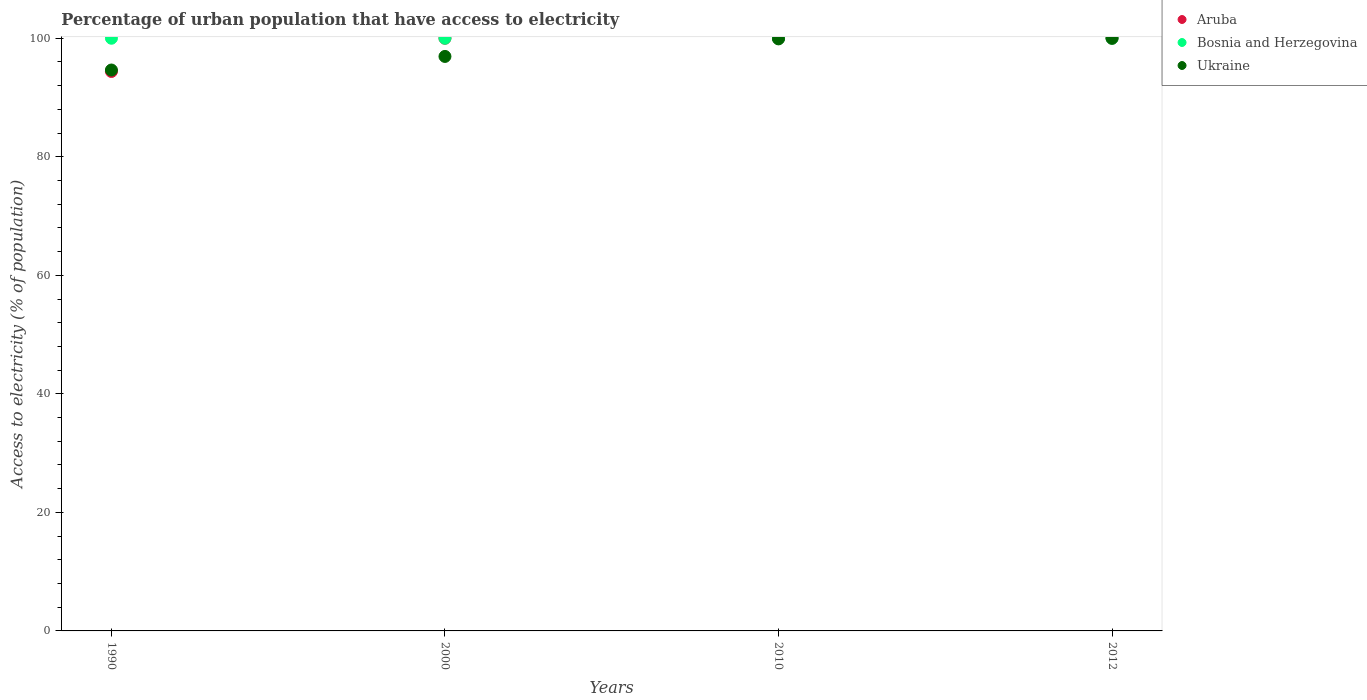What is the percentage of urban population that have access to electricity in Bosnia and Herzegovina in 2010?
Offer a very short reply. 100. Across all years, what is the maximum percentage of urban population that have access to electricity in Bosnia and Herzegovina?
Your response must be concise. 100. Across all years, what is the minimum percentage of urban population that have access to electricity in Aruba?
Keep it short and to the point. 94.39. In which year was the percentage of urban population that have access to electricity in Aruba maximum?
Offer a terse response. 2000. What is the total percentage of urban population that have access to electricity in Ukraine in the graph?
Offer a terse response. 391.46. What is the difference between the percentage of urban population that have access to electricity in Ukraine in 2010 and that in 2012?
Provide a short and direct response. -0.11. What is the difference between the percentage of urban population that have access to electricity in Ukraine in 1990 and the percentage of urban population that have access to electricity in Bosnia and Herzegovina in 2010?
Your answer should be very brief. -5.36. What is the average percentage of urban population that have access to electricity in Bosnia and Herzegovina per year?
Provide a short and direct response. 100. In the year 2012, what is the difference between the percentage of urban population that have access to electricity in Ukraine and percentage of urban population that have access to electricity in Aruba?
Your answer should be very brief. 0. In how many years, is the percentage of urban population that have access to electricity in Bosnia and Herzegovina greater than 20 %?
Ensure brevity in your answer.  4. Is the percentage of urban population that have access to electricity in Ukraine in 2010 less than that in 2012?
Offer a terse response. Yes. Is the difference between the percentage of urban population that have access to electricity in Ukraine in 1990 and 2012 greater than the difference between the percentage of urban population that have access to electricity in Aruba in 1990 and 2012?
Provide a succinct answer. Yes. What is the difference between the highest and the lowest percentage of urban population that have access to electricity in Aruba?
Provide a succinct answer. 5.61. Does the percentage of urban population that have access to electricity in Ukraine monotonically increase over the years?
Provide a short and direct response. Yes. Is the percentage of urban population that have access to electricity in Ukraine strictly greater than the percentage of urban population that have access to electricity in Bosnia and Herzegovina over the years?
Your response must be concise. No. What is the difference between two consecutive major ticks on the Y-axis?
Provide a succinct answer. 20. Does the graph contain any zero values?
Ensure brevity in your answer.  No. How are the legend labels stacked?
Give a very brief answer. Vertical. What is the title of the graph?
Ensure brevity in your answer.  Percentage of urban population that have access to electricity. What is the label or title of the X-axis?
Your answer should be very brief. Years. What is the label or title of the Y-axis?
Your answer should be compact. Access to electricity (% of population). What is the Access to electricity (% of population) of Aruba in 1990?
Make the answer very short. 94.39. What is the Access to electricity (% of population) in Ukraine in 1990?
Your answer should be very brief. 94.64. What is the Access to electricity (% of population) in Ukraine in 2000?
Offer a very short reply. 96.93. What is the Access to electricity (% of population) in Bosnia and Herzegovina in 2010?
Your answer should be compact. 100. What is the Access to electricity (% of population) in Ukraine in 2010?
Ensure brevity in your answer.  99.89. Across all years, what is the maximum Access to electricity (% of population) in Aruba?
Provide a succinct answer. 100. Across all years, what is the maximum Access to electricity (% of population) in Bosnia and Herzegovina?
Your response must be concise. 100. Across all years, what is the minimum Access to electricity (% of population) of Aruba?
Make the answer very short. 94.39. Across all years, what is the minimum Access to electricity (% of population) of Ukraine?
Ensure brevity in your answer.  94.64. What is the total Access to electricity (% of population) of Aruba in the graph?
Offer a terse response. 394.39. What is the total Access to electricity (% of population) in Ukraine in the graph?
Your answer should be compact. 391.46. What is the difference between the Access to electricity (% of population) of Aruba in 1990 and that in 2000?
Provide a short and direct response. -5.61. What is the difference between the Access to electricity (% of population) of Bosnia and Herzegovina in 1990 and that in 2000?
Your response must be concise. 0. What is the difference between the Access to electricity (% of population) in Ukraine in 1990 and that in 2000?
Make the answer very short. -2.29. What is the difference between the Access to electricity (% of population) in Aruba in 1990 and that in 2010?
Your answer should be very brief. -5.61. What is the difference between the Access to electricity (% of population) in Ukraine in 1990 and that in 2010?
Offer a very short reply. -5.25. What is the difference between the Access to electricity (% of population) of Aruba in 1990 and that in 2012?
Make the answer very short. -5.61. What is the difference between the Access to electricity (% of population) in Ukraine in 1990 and that in 2012?
Your answer should be compact. -5.36. What is the difference between the Access to electricity (% of population) of Aruba in 2000 and that in 2010?
Your answer should be very brief. 0. What is the difference between the Access to electricity (% of population) in Ukraine in 2000 and that in 2010?
Your answer should be very brief. -2.96. What is the difference between the Access to electricity (% of population) of Aruba in 2000 and that in 2012?
Your answer should be compact. 0. What is the difference between the Access to electricity (% of population) in Ukraine in 2000 and that in 2012?
Offer a very short reply. -3.07. What is the difference between the Access to electricity (% of population) in Aruba in 2010 and that in 2012?
Your answer should be compact. 0. What is the difference between the Access to electricity (% of population) of Ukraine in 2010 and that in 2012?
Keep it short and to the point. -0.11. What is the difference between the Access to electricity (% of population) of Aruba in 1990 and the Access to electricity (% of population) of Bosnia and Herzegovina in 2000?
Ensure brevity in your answer.  -5.61. What is the difference between the Access to electricity (% of population) in Aruba in 1990 and the Access to electricity (% of population) in Ukraine in 2000?
Your response must be concise. -2.54. What is the difference between the Access to electricity (% of population) in Bosnia and Herzegovina in 1990 and the Access to electricity (% of population) in Ukraine in 2000?
Give a very brief answer. 3.07. What is the difference between the Access to electricity (% of population) in Aruba in 1990 and the Access to electricity (% of population) in Bosnia and Herzegovina in 2010?
Your answer should be compact. -5.61. What is the difference between the Access to electricity (% of population) in Aruba in 1990 and the Access to electricity (% of population) in Ukraine in 2010?
Provide a short and direct response. -5.5. What is the difference between the Access to electricity (% of population) in Bosnia and Herzegovina in 1990 and the Access to electricity (% of population) in Ukraine in 2010?
Keep it short and to the point. 0.11. What is the difference between the Access to electricity (% of population) of Aruba in 1990 and the Access to electricity (% of population) of Bosnia and Herzegovina in 2012?
Offer a terse response. -5.61. What is the difference between the Access to electricity (% of population) in Aruba in 1990 and the Access to electricity (% of population) in Ukraine in 2012?
Offer a very short reply. -5.61. What is the difference between the Access to electricity (% of population) in Aruba in 2000 and the Access to electricity (% of population) in Ukraine in 2010?
Your answer should be compact. 0.11. What is the difference between the Access to electricity (% of population) in Bosnia and Herzegovina in 2000 and the Access to electricity (% of population) in Ukraine in 2010?
Your response must be concise. 0.11. What is the difference between the Access to electricity (% of population) of Aruba in 2000 and the Access to electricity (% of population) of Bosnia and Herzegovina in 2012?
Keep it short and to the point. 0. What is the difference between the Access to electricity (% of population) of Aruba in 2010 and the Access to electricity (% of population) of Bosnia and Herzegovina in 2012?
Offer a terse response. 0. What is the difference between the Access to electricity (% of population) of Aruba in 2010 and the Access to electricity (% of population) of Ukraine in 2012?
Make the answer very short. 0. What is the difference between the Access to electricity (% of population) of Bosnia and Herzegovina in 2010 and the Access to electricity (% of population) of Ukraine in 2012?
Your answer should be compact. 0. What is the average Access to electricity (% of population) in Aruba per year?
Keep it short and to the point. 98.6. What is the average Access to electricity (% of population) of Bosnia and Herzegovina per year?
Give a very brief answer. 100. What is the average Access to electricity (% of population) of Ukraine per year?
Offer a terse response. 97.86. In the year 1990, what is the difference between the Access to electricity (% of population) of Aruba and Access to electricity (% of population) of Bosnia and Herzegovina?
Keep it short and to the point. -5.61. In the year 1990, what is the difference between the Access to electricity (% of population) in Aruba and Access to electricity (% of population) in Ukraine?
Your answer should be very brief. -0.25. In the year 1990, what is the difference between the Access to electricity (% of population) in Bosnia and Herzegovina and Access to electricity (% of population) in Ukraine?
Provide a short and direct response. 5.36. In the year 2000, what is the difference between the Access to electricity (% of population) in Aruba and Access to electricity (% of population) in Bosnia and Herzegovina?
Your answer should be very brief. 0. In the year 2000, what is the difference between the Access to electricity (% of population) in Aruba and Access to electricity (% of population) in Ukraine?
Offer a very short reply. 3.07. In the year 2000, what is the difference between the Access to electricity (% of population) of Bosnia and Herzegovina and Access to electricity (% of population) of Ukraine?
Your answer should be compact. 3.07. In the year 2010, what is the difference between the Access to electricity (% of population) of Aruba and Access to electricity (% of population) of Bosnia and Herzegovina?
Your answer should be very brief. 0. In the year 2010, what is the difference between the Access to electricity (% of population) of Aruba and Access to electricity (% of population) of Ukraine?
Keep it short and to the point. 0.11. In the year 2010, what is the difference between the Access to electricity (% of population) of Bosnia and Herzegovina and Access to electricity (% of population) of Ukraine?
Your answer should be compact. 0.11. In the year 2012, what is the difference between the Access to electricity (% of population) in Aruba and Access to electricity (% of population) in Ukraine?
Provide a succinct answer. 0. What is the ratio of the Access to electricity (% of population) in Aruba in 1990 to that in 2000?
Your answer should be very brief. 0.94. What is the ratio of the Access to electricity (% of population) of Ukraine in 1990 to that in 2000?
Your response must be concise. 0.98. What is the ratio of the Access to electricity (% of population) in Aruba in 1990 to that in 2010?
Provide a succinct answer. 0.94. What is the ratio of the Access to electricity (% of population) of Bosnia and Herzegovina in 1990 to that in 2010?
Provide a succinct answer. 1. What is the ratio of the Access to electricity (% of population) of Ukraine in 1990 to that in 2010?
Keep it short and to the point. 0.95. What is the ratio of the Access to electricity (% of population) in Aruba in 1990 to that in 2012?
Make the answer very short. 0.94. What is the ratio of the Access to electricity (% of population) of Ukraine in 1990 to that in 2012?
Your response must be concise. 0.95. What is the ratio of the Access to electricity (% of population) in Bosnia and Herzegovina in 2000 to that in 2010?
Provide a short and direct response. 1. What is the ratio of the Access to electricity (% of population) of Ukraine in 2000 to that in 2010?
Ensure brevity in your answer.  0.97. What is the ratio of the Access to electricity (% of population) of Bosnia and Herzegovina in 2000 to that in 2012?
Give a very brief answer. 1. What is the ratio of the Access to electricity (% of population) in Ukraine in 2000 to that in 2012?
Offer a very short reply. 0.97. What is the ratio of the Access to electricity (% of population) in Aruba in 2010 to that in 2012?
Keep it short and to the point. 1. What is the ratio of the Access to electricity (% of population) of Ukraine in 2010 to that in 2012?
Make the answer very short. 1. What is the difference between the highest and the second highest Access to electricity (% of population) in Aruba?
Your answer should be compact. 0. What is the difference between the highest and the second highest Access to electricity (% of population) in Ukraine?
Make the answer very short. 0.11. What is the difference between the highest and the lowest Access to electricity (% of population) of Aruba?
Offer a terse response. 5.61. What is the difference between the highest and the lowest Access to electricity (% of population) in Ukraine?
Give a very brief answer. 5.36. 